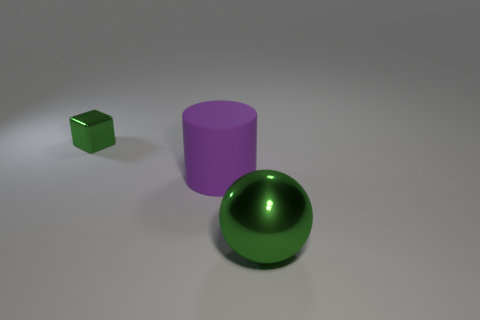Add 1 tiny metallic cubes. How many objects exist? 4 Subtract all spheres. How many objects are left? 2 Subtract all small green blocks. Subtract all big green metallic cylinders. How many objects are left? 2 Add 1 large green metallic spheres. How many large green metallic spheres are left? 2 Add 3 large rubber cylinders. How many large rubber cylinders exist? 4 Subtract 0 brown spheres. How many objects are left? 3 Subtract 1 cylinders. How many cylinders are left? 0 